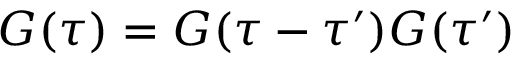<formula> <loc_0><loc_0><loc_500><loc_500>G ( \tau ) = G ( \tau - \tau ^ { \prime } ) G ( \tau ^ { \prime } )</formula> 